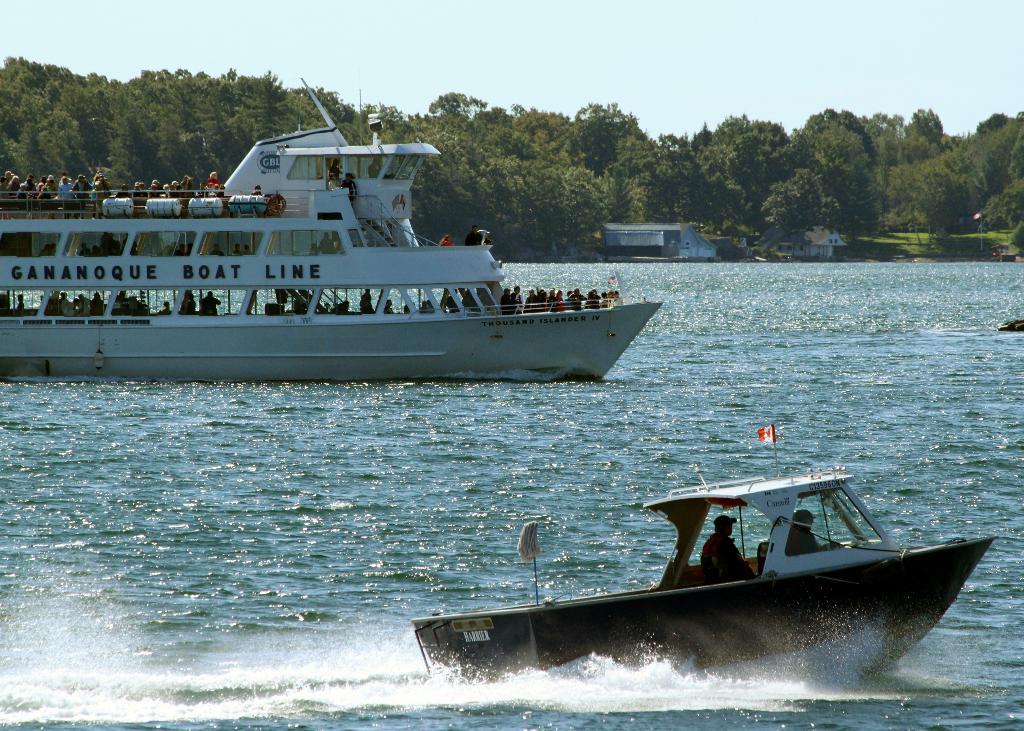Can you describe this image briefly? We can see ships above the water and we can see people in ships. Background we can see trees,houses,grass and sky. 